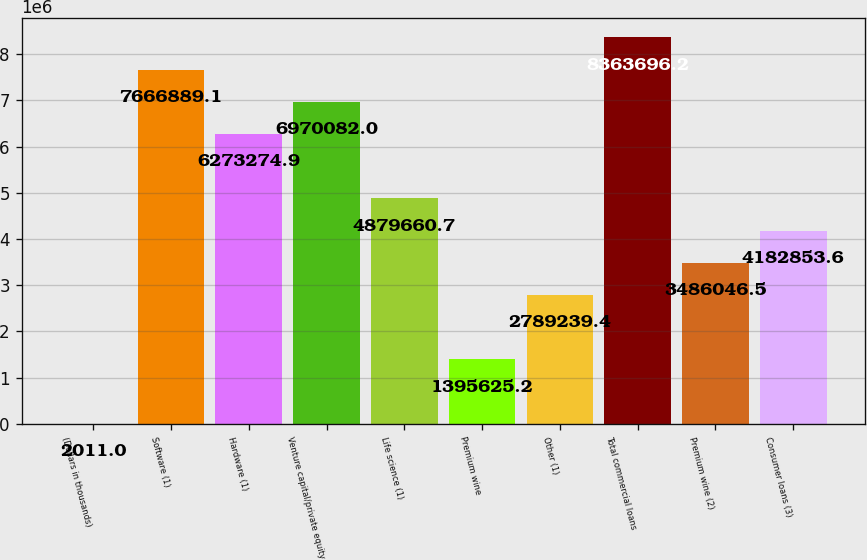<chart> <loc_0><loc_0><loc_500><loc_500><bar_chart><fcel>(Dollars in thousands)<fcel>Software (1)<fcel>Hardware (1)<fcel>Venture capital/private equity<fcel>Life science (1)<fcel>Premium wine<fcel>Other (1)<fcel>Total commercial loans<fcel>Premium wine (2)<fcel>Consumer loans (3)<nl><fcel>2011<fcel>7.66689e+06<fcel>6.27327e+06<fcel>6.97008e+06<fcel>4.87966e+06<fcel>1.39563e+06<fcel>2.78924e+06<fcel>8.3637e+06<fcel>3.48605e+06<fcel>4.18285e+06<nl></chart> 